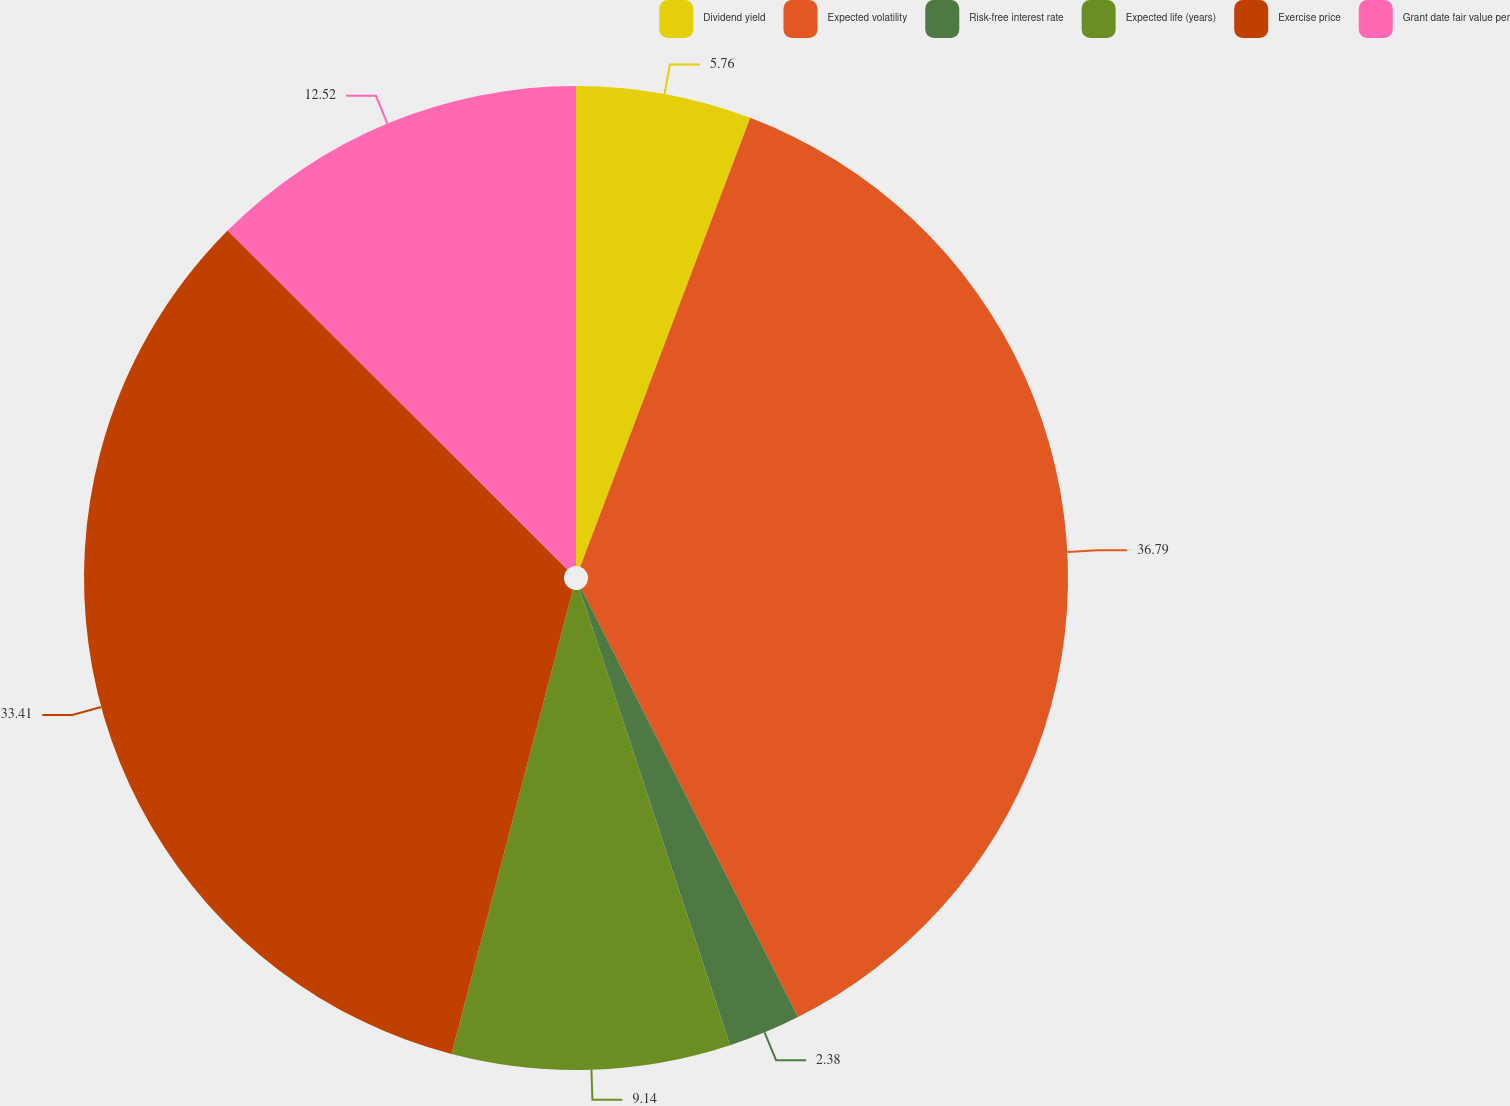Convert chart to OTSL. <chart><loc_0><loc_0><loc_500><loc_500><pie_chart><fcel>Dividend yield<fcel>Expected volatility<fcel>Risk-free interest rate<fcel>Expected life (years)<fcel>Exercise price<fcel>Grant date fair value per<nl><fcel>5.76%<fcel>36.79%<fcel>2.38%<fcel>9.14%<fcel>33.41%<fcel>12.52%<nl></chart> 